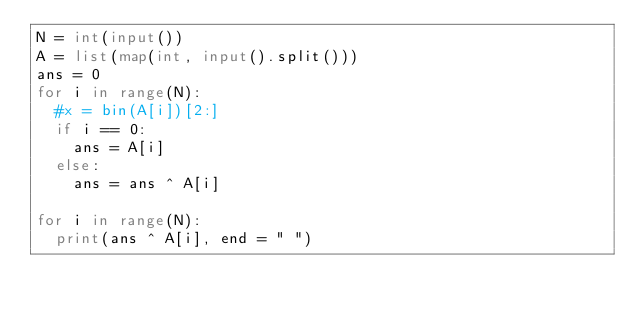<code> <loc_0><loc_0><loc_500><loc_500><_Python_>N = int(input())
A = list(map(int, input().split()))
ans = 0
for i in range(N):
  #x = bin(A[i])[2:]
  if i == 0:
    ans = A[i]
  else:
    ans = ans ^ A[i]
    
for i in range(N):
  print(ans ^ A[i], end = " ")



</code> 